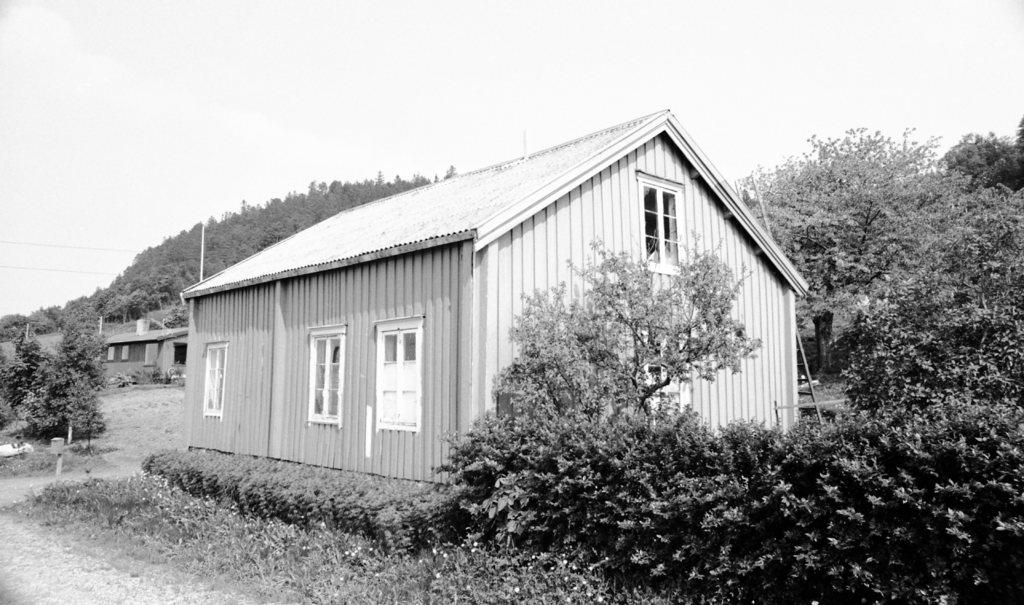What is the main structure in the middle of the image? There is a house in the middle of the image. What type of vegetation is visible around the house? Trees and bushes are visible around the house. What is visible at the top of the image? The sky is visible at the top of the image. How does the house sense the presence of a visitor in the image? The house does not have the ability to sense the presence of a visitor, as it is an inanimate object. 